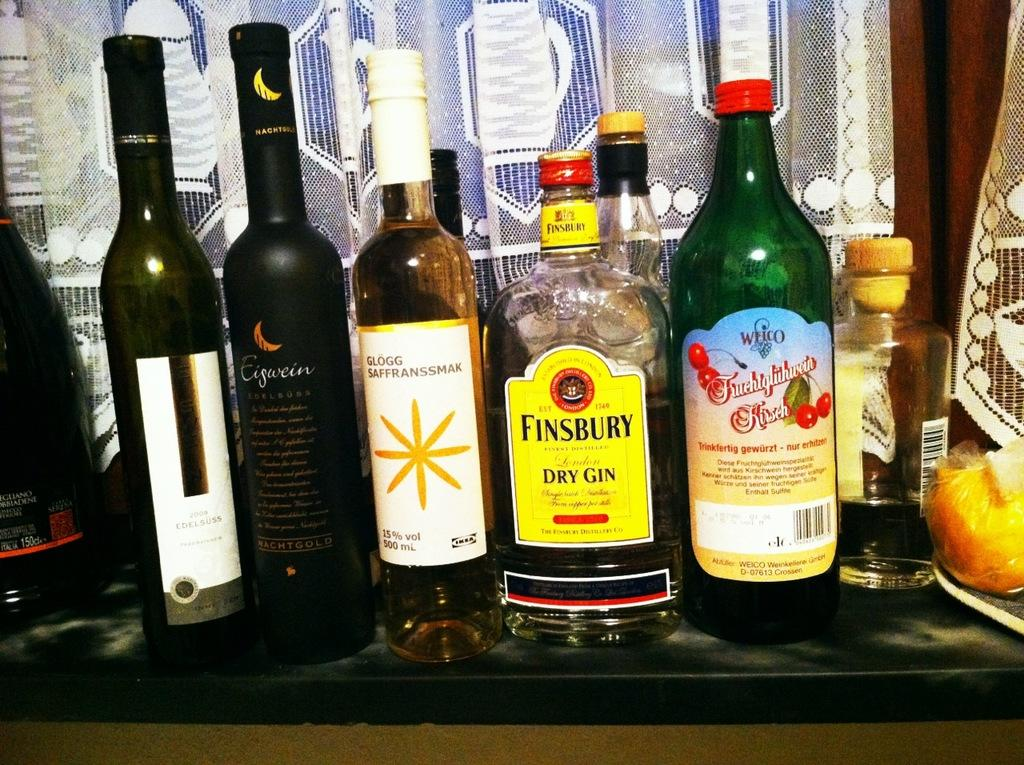What is located in the middle of the image? There are bottles in the middle of the image. What is present at the bottom of the image? There is a table at the bottom of the image. Can you describe the object in the bottom right of the image? There is an object on yellow color in the bottom right of the image. Are there any boats visible in the image? No, there are no boats present in the image. Is this image taken during a vacation? The image does not provide any information about the context or location, so it cannot be determined if it was taken during a vacation. 